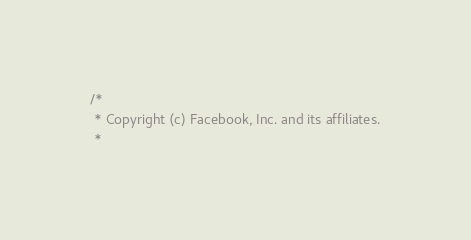Convert code to text. <code><loc_0><loc_0><loc_500><loc_500><_ObjectiveC_>/*
 * Copyright (c) Facebook, Inc. and its affiliates.
 *</code> 